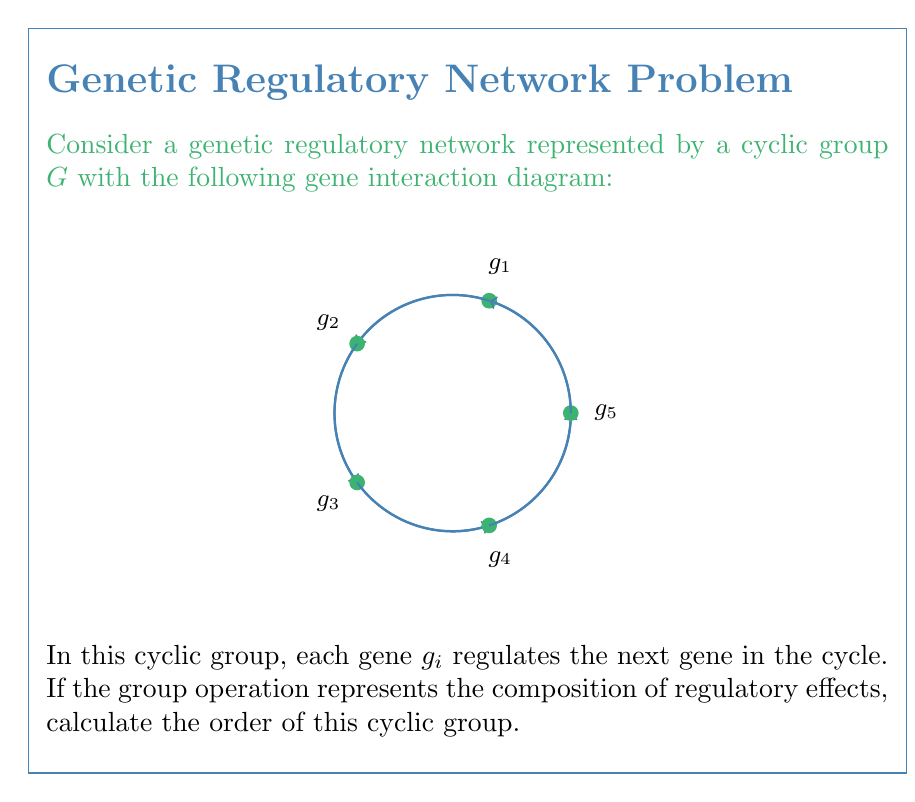Teach me how to tackle this problem. To solve this problem, we need to follow these steps:

1) First, we need to identify the generator of the cyclic group. In this case, any element $g_i$ can be chosen as the generator, as they all produce the same cyclic group. Let's choose $g_1$ as our generator.

2) The order of a cyclic group is equal to the smallest positive integer $n$ such that $g^n = e$, where $g$ is the generator and $e$ is the identity element.

3) In our genetic regulatory network, each application of $g_1$ shifts the regulation by one step. We need to determine how many times we need to apply $g_1$ to return to the original state.

4) Observing the diagram, we can see that there are 5 genes in the cycle. This means:

   $g_1^1 = g_1$ (shift by 1)
   $g_1^2 = g_2$ (shift by 2)
   $g_1^3 = g_3$ (shift by 3)
   $g_1^4 = g_4$ (shift by 4)
   $g_1^5 = g_5 = g_1$ (shift by 5, which brings us back to the start)

5) Therefore, the smallest positive integer $n$ such that $g_1^n = g_1$ (the identity in this context) is 5.

6) Thus, the order of the cyclic group is 5.

This cyclic group of order 5 represents the rotational symmetry of the genetic regulatory network, where each gene regulates the next in a cyclic manner.
Answer: 5 